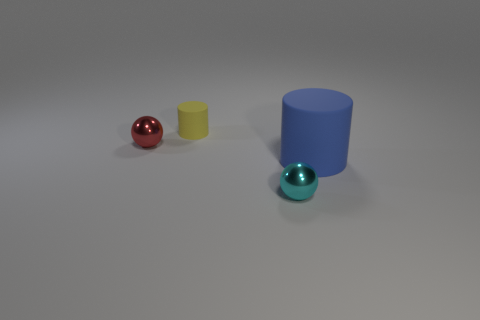Add 1 small cyan balls. How many objects exist? 5 Add 4 large purple matte blocks. How many large purple matte blocks exist? 4 Subtract 0 purple cubes. How many objects are left? 4 Subtract all cyan shiny cylinders. Subtract all large matte objects. How many objects are left? 3 Add 1 red metallic things. How many red metallic things are left? 2 